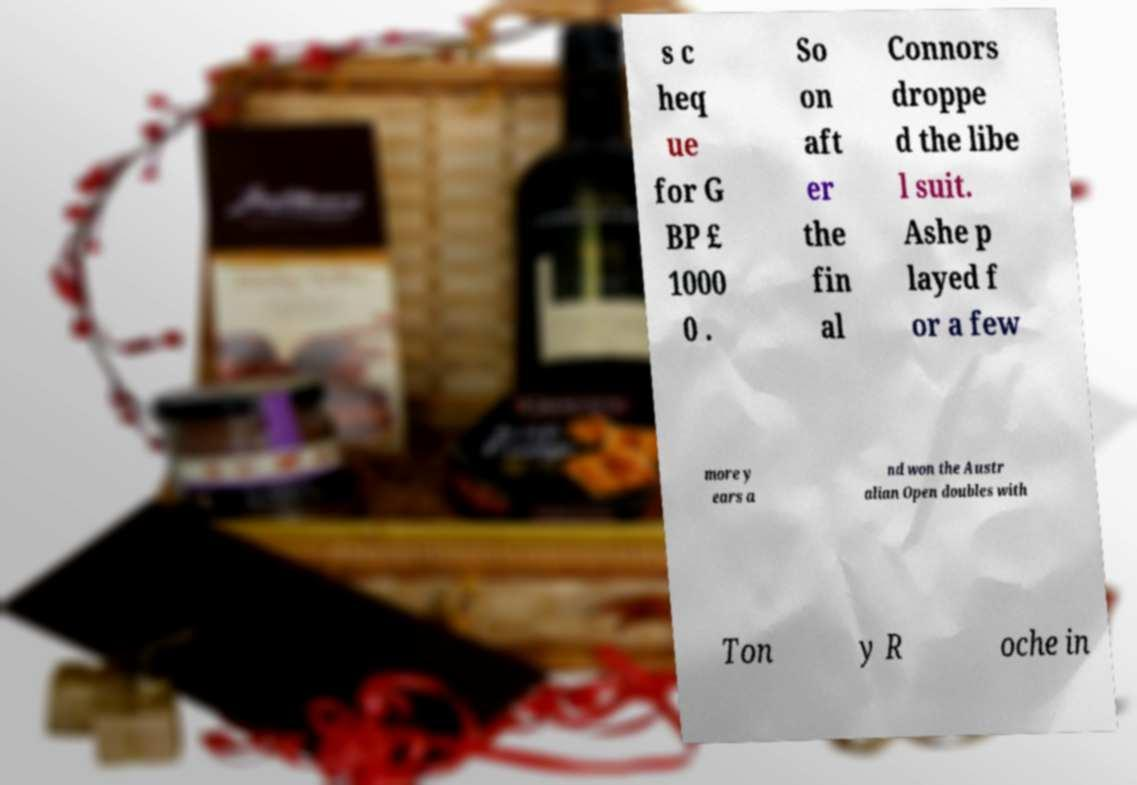Please identify and transcribe the text found in this image. s c heq ue for G BP £ 1000 0 . So on aft er the fin al Connors droppe d the libe l suit. Ashe p layed f or a few more y ears a nd won the Austr alian Open doubles with Ton y R oche in 